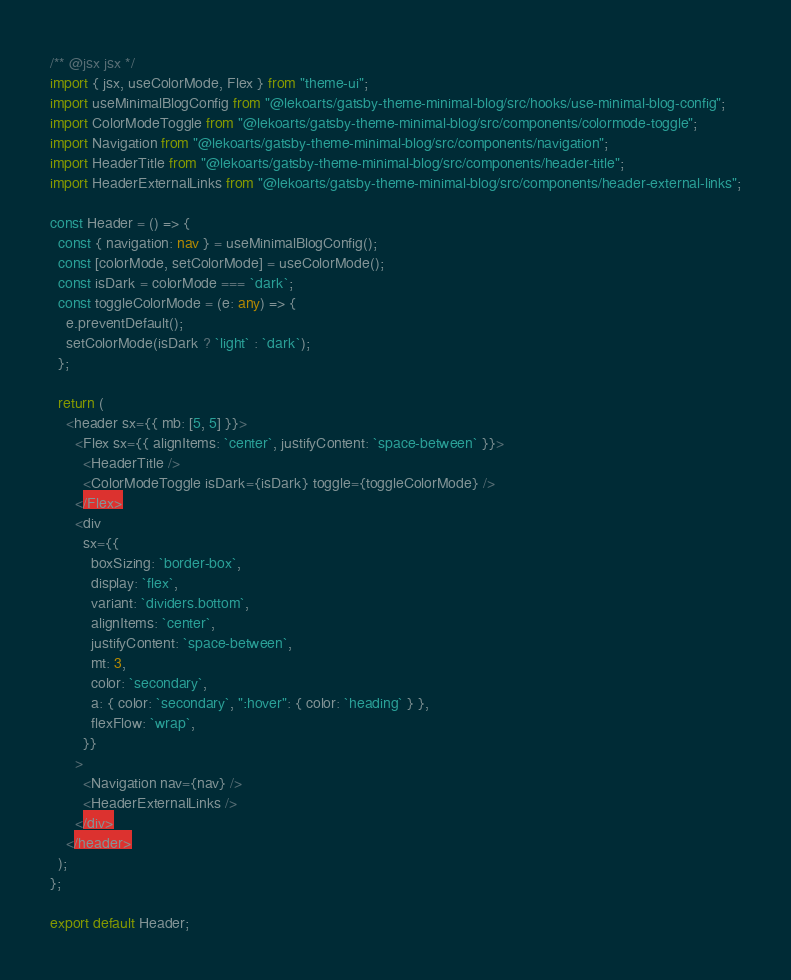Convert code to text. <code><loc_0><loc_0><loc_500><loc_500><_TypeScript_>/** @jsx jsx */
import { jsx, useColorMode, Flex } from "theme-ui";
import useMinimalBlogConfig from "@lekoarts/gatsby-theme-minimal-blog/src/hooks/use-minimal-blog-config";
import ColorModeToggle from "@lekoarts/gatsby-theme-minimal-blog/src/components/colormode-toggle";
import Navigation from "@lekoarts/gatsby-theme-minimal-blog/src/components/navigation";
import HeaderTitle from "@lekoarts/gatsby-theme-minimal-blog/src/components/header-title";
import HeaderExternalLinks from "@lekoarts/gatsby-theme-minimal-blog/src/components/header-external-links";

const Header = () => {
  const { navigation: nav } = useMinimalBlogConfig();
  const [colorMode, setColorMode] = useColorMode();
  const isDark = colorMode === `dark`;
  const toggleColorMode = (e: any) => {
    e.preventDefault();
    setColorMode(isDark ? `light` : `dark`);
  };

  return (
    <header sx={{ mb: [5, 5] }}>
      <Flex sx={{ alignItems: `center`, justifyContent: `space-between` }}>
        <HeaderTitle />
        <ColorModeToggle isDark={isDark} toggle={toggleColorMode} />
      </Flex>
      <div
        sx={{
          boxSizing: `border-box`,
          display: `flex`,
          variant: `dividers.bottom`,
          alignItems: `center`,
          justifyContent: `space-between`,
          mt: 3,
          color: `secondary`,
          a: { color: `secondary`, ":hover": { color: `heading` } },
          flexFlow: `wrap`,
        }}
      >
        <Navigation nav={nav} />
        <HeaderExternalLinks />
      </div>
    </header>
  );
};

export default Header;
</code> 